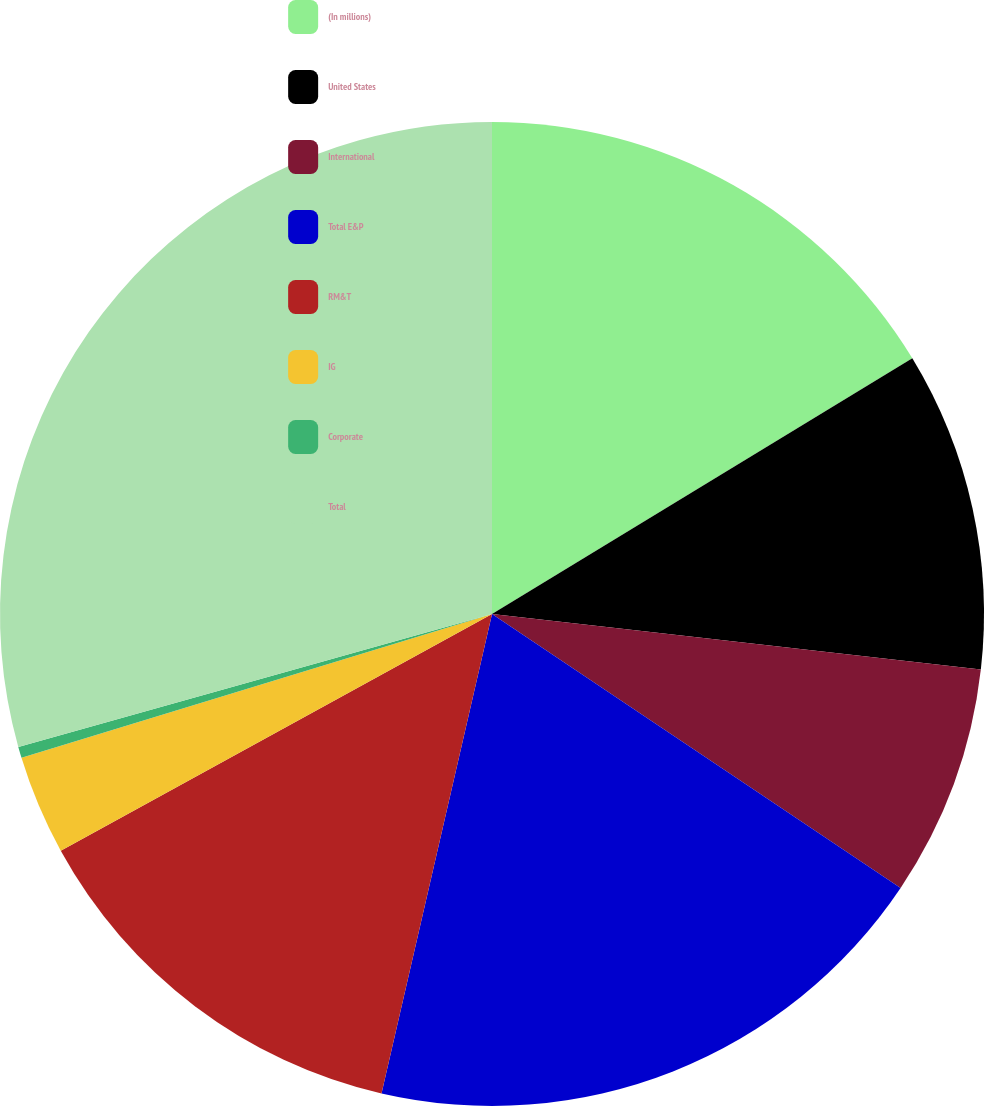Convert chart to OTSL. <chart><loc_0><loc_0><loc_500><loc_500><pie_chart><fcel>(In millions)<fcel>United States<fcel>International<fcel>Total E&P<fcel>RM&T<fcel>IG<fcel>Corporate<fcel>Total<nl><fcel>16.3%<fcel>10.5%<fcel>7.6%<fcel>19.2%<fcel>13.4%<fcel>3.27%<fcel>0.37%<fcel>29.35%<nl></chart> 